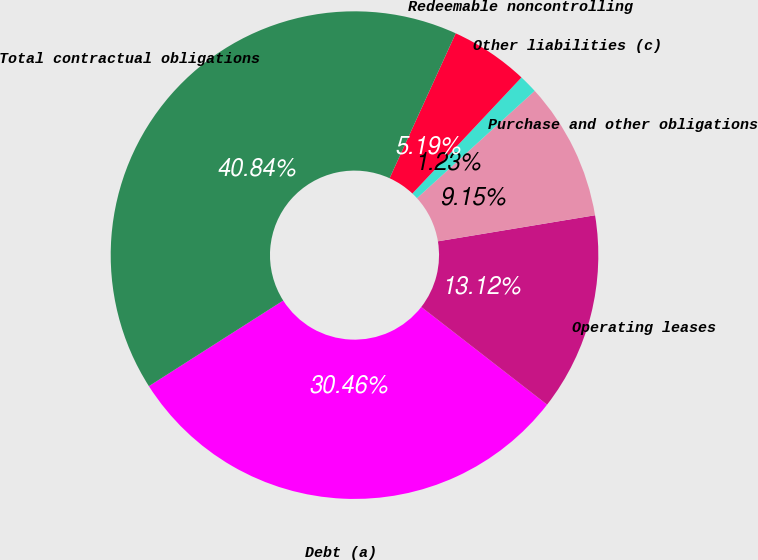Convert chart. <chart><loc_0><loc_0><loc_500><loc_500><pie_chart><fcel>Debt (a)<fcel>Operating leases<fcel>Purchase and other obligations<fcel>Other liabilities (c)<fcel>Redeemable noncontrolling<fcel>Total contractual obligations<nl><fcel>30.46%<fcel>13.12%<fcel>9.15%<fcel>1.23%<fcel>5.19%<fcel>40.84%<nl></chart> 